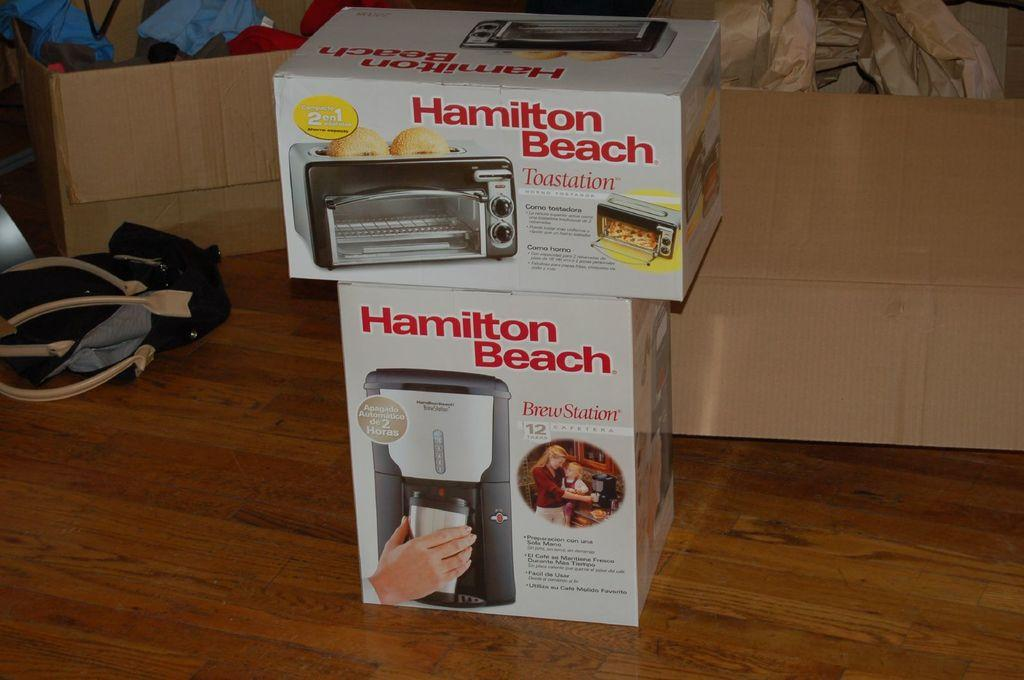<image>
Provide a brief description of the given image. A toaster over box by hamilton beach sitting on top of a coffee maker box. 